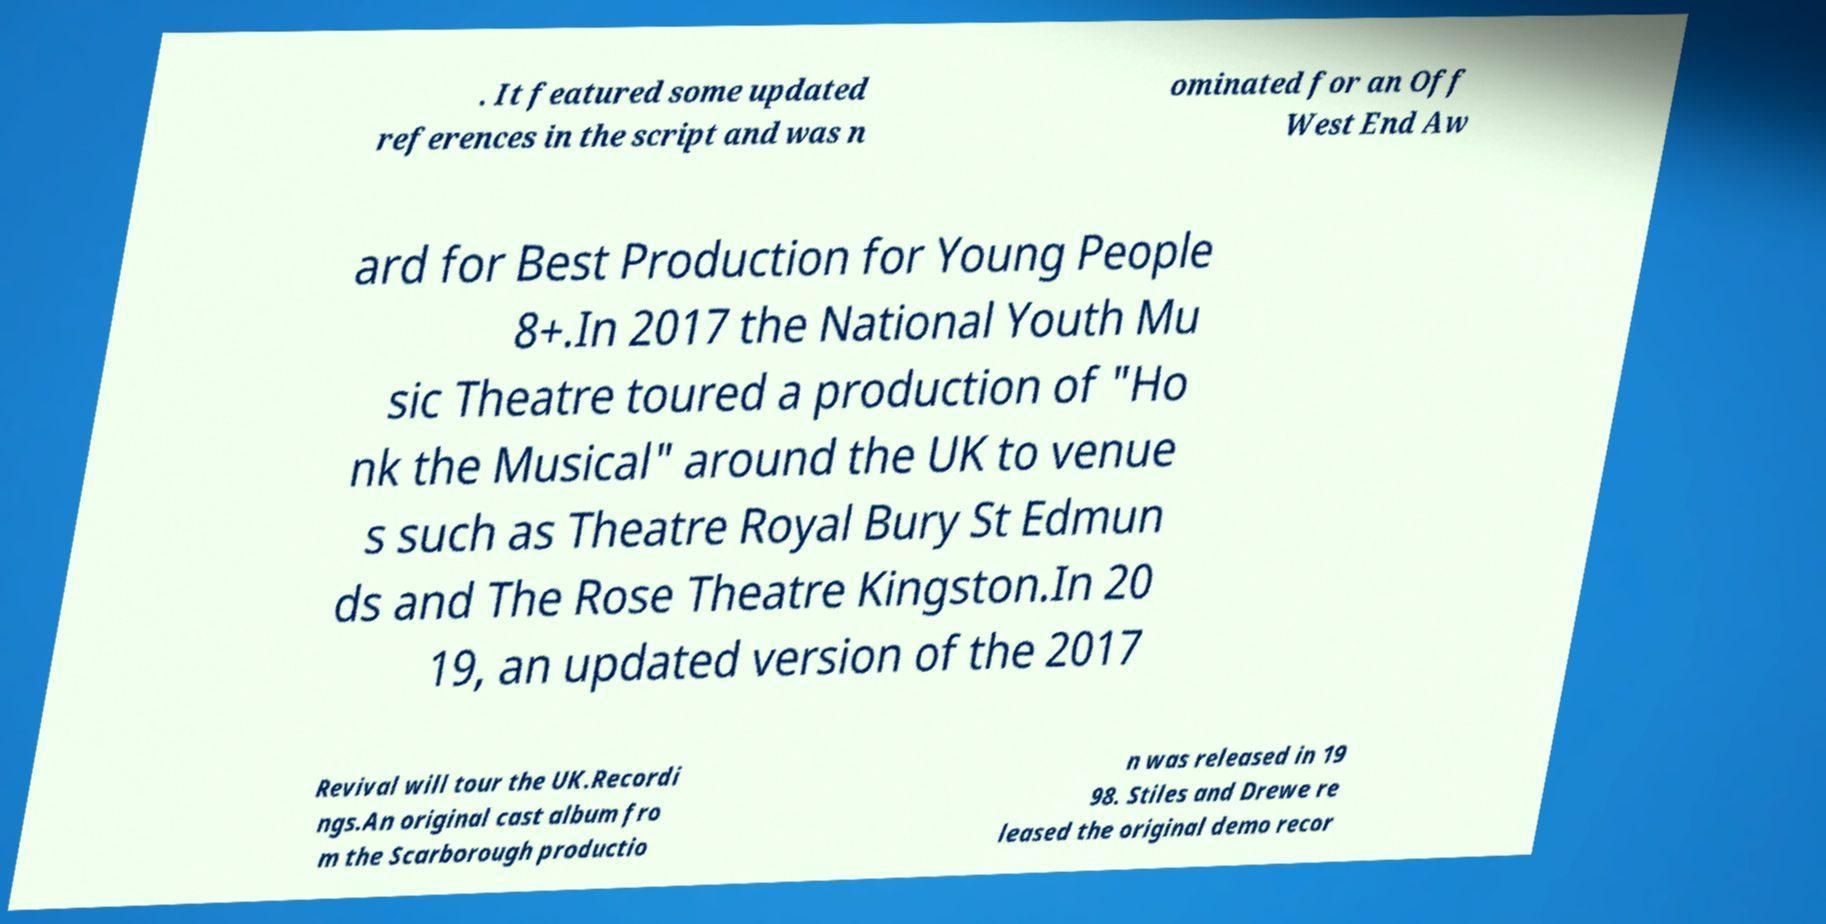For documentation purposes, I need the text within this image transcribed. Could you provide that? . It featured some updated references in the script and was n ominated for an Off West End Aw ard for Best Production for Young People 8+.In 2017 the National Youth Mu sic Theatre toured a production of "Ho nk the Musical" around the UK to venue s such as Theatre Royal Bury St Edmun ds and The Rose Theatre Kingston.In 20 19, an updated version of the 2017 Revival will tour the UK.Recordi ngs.An original cast album fro m the Scarborough productio n was released in 19 98. Stiles and Drewe re leased the original demo recor 